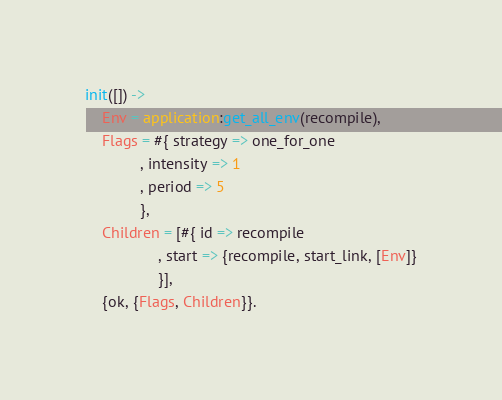<code> <loc_0><loc_0><loc_500><loc_500><_Erlang_>
init([]) ->
    Env = application:get_all_env(recompile),
    Flags = #{ strategy => one_for_one
             , intensity => 1
             , period => 5
             },
    Children = [#{ id => recompile
                 , start => {recompile, start_link, [Env]}
                 }],
    {ok, {Flags, Children}}.
</code> 